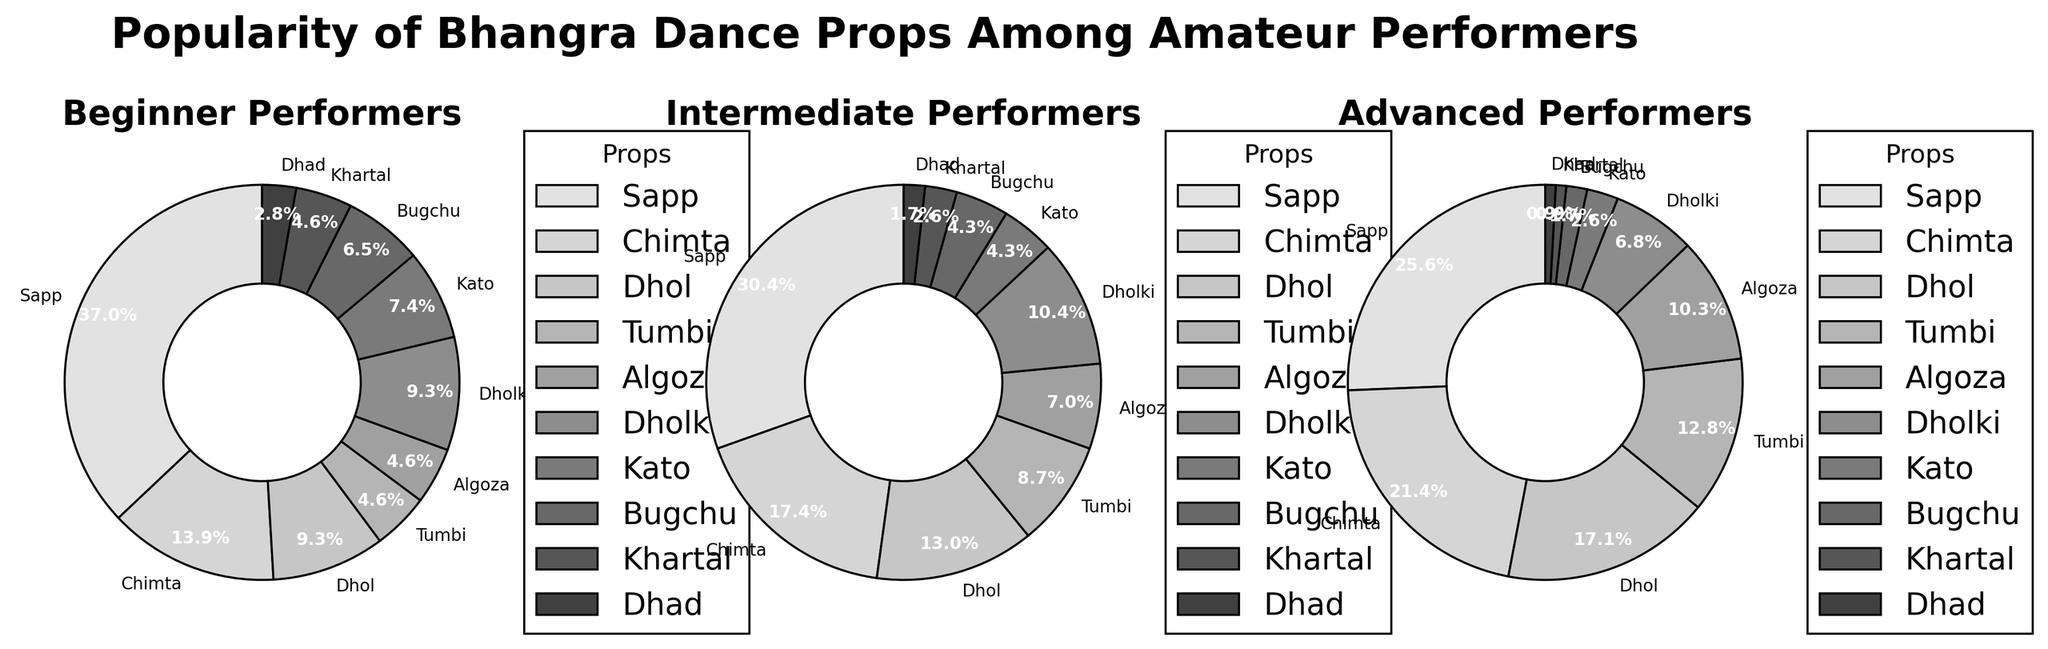Popularitywise which prop appears to be the most favored among beginners? The figure for "Beginner Performers" shows the largest pie slice is labeled "Sapp" at 40%.
Answer: Sapp How does the popularity percentage of "Dhol" compare between intermediate and advanced performers? In the figure, the slice for "Dhol" among Intermediate Performers is 15%, while for Advanced Performers, it is 20%.
Answer: Dhol is more popular among advanced performers Which level of performers shows the least interest in "Kato"? Looking at the size of the "Kato" wedge in all three charts, Advanced Performers have the smallest percentage at 3%.
Answer: Advanced What's the sum of the popularity percentages of "Algoza" and "Bugchu" among intermediate performers? "Algoza" has 8% and "Bugchu" has 5% among Intermediate Performers. Summing these gives 8% + 5% = 13%.
Answer: 13% For "Khartal", which group has the lowest percentage, and what is it? The pie slice for "Khartal" indicates 1% among Advanced Performers, which is the lowest compared to Beginners and Intermediates.
Answer: Advanced at 1% How much more popular is "Tumbi" among advanced performers compared to beginners? From the pie chart, "Tumbi" is 15% for Advanced Performers and 5% for Beginners. The difference is 15% - 5% = 10%.
Answer: 10% more What is the average percentage for "Chimta" across all performer levels? "Chimta" percentages are 15% (Beginner), 20% (Intermediate), and 25% (Advanced). The average is (15% + 20% + 25%) / 3 = 20%.
Answer: 20% Compare the total percentages for "Sapp" and "Dholki" among beginner performers. Which is higher? For Beginners, "Sapp" is 40% and "Dholki" is 10%. 40% > 10%, so "Sapp" is higher.
Answer: Sapp is higher How do the visual slice sizes for "Dhad" differ among all performance levels? The "Dhad" slice appears smallest across all charts: 3% (Beginner), 2% (Intermediate), 1% (Advanced), visibly reducing in size across the levels.
Answer: Gets smaller from Beginner to Advanced 